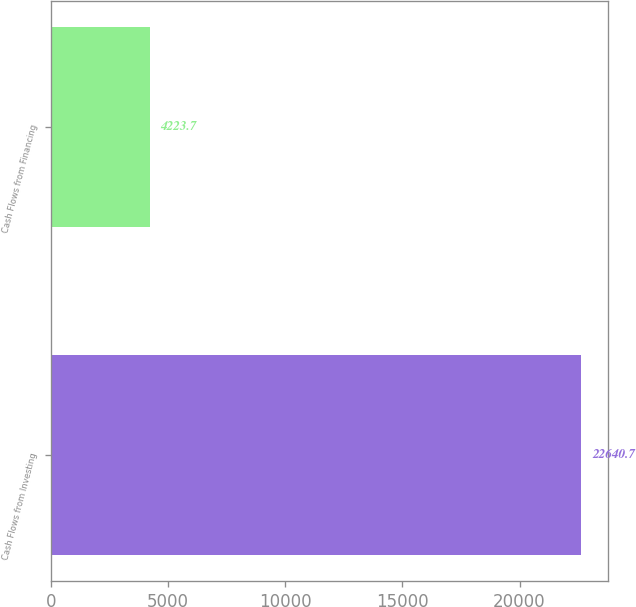<chart> <loc_0><loc_0><loc_500><loc_500><bar_chart><fcel>Cash Flows from Investing<fcel>Cash Flows from Financing<nl><fcel>22640.7<fcel>4223.7<nl></chart> 